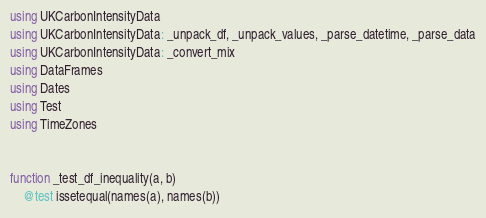Convert code to text. <code><loc_0><loc_0><loc_500><loc_500><_Julia_>using UKCarbonIntensityData
using UKCarbonIntensityData: _unpack_df, _unpack_values, _parse_datetime, _parse_data
using UKCarbonIntensityData: _convert_mix
using DataFrames
using Dates
using Test
using TimeZones


function _test_df_inequality(a, b)
    @test issetequal(names(a), names(b))</code> 